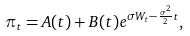<formula> <loc_0><loc_0><loc_500><loc_500>\pi _ { t } = A ( t ) + B ( t ) e ^ { \sigma W _ { t } - \frac { \sigma ^ { 2 } } { 2 } t } ,</formula> 